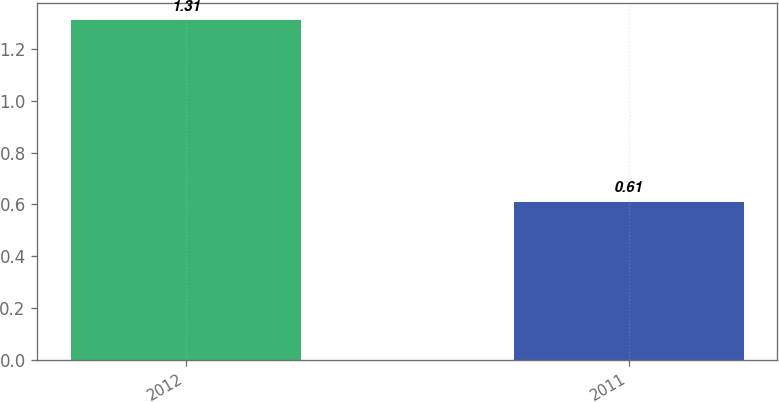<chart> <loc_0><loc_0><loc_500><loc_500><bar_chart><fcel>2012<fcel>2011<nl><fcel>1.31<fcel>0.61<nl></chart> 